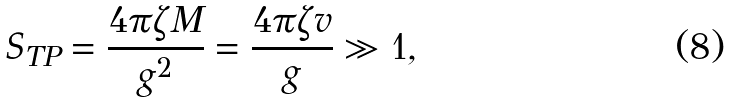Convert formula to latex. <formula><loc_0><loc_0><loc_500><loc_500>S _ { T P } = \frac { 4 \pi \zeta M } { g ^ { 2 } } = \frac { 4 \pi \zeta v } { g } \gg 1 ,</formula> 